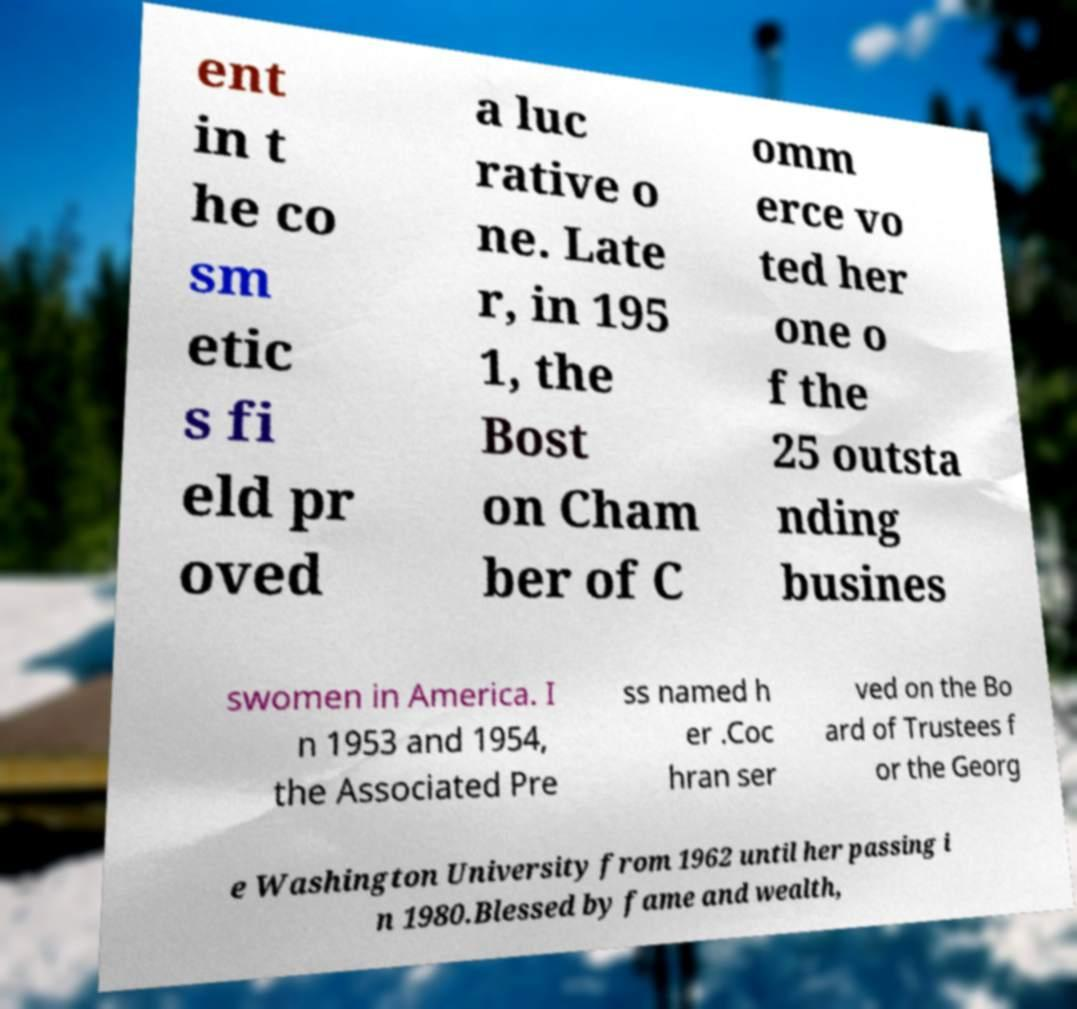I need the written content from this picture converted into text. Can you do that? ent in t he co sm etic s fi eld pr oved a luc rative o ne. Late r, in 195 1, the Bost on Cham ber of C omm erce vo ted her one o f the 25 outsta nding busines swomen in America. I n 1953 and 1954, the Associated Pre ss named h er .Coc hran ser ved on the Bo ard of Trustees f or the Georg e Washington University from 1962 until her passing i n 1980.Blessed by fame and wealth, 